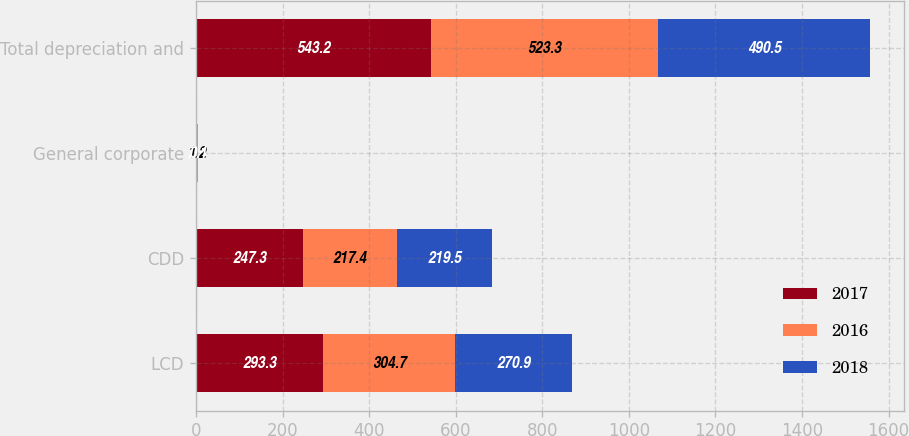<chart> <loc_0><loc_0><loc_500><loc_500><stacked_bar_chart><ecel><fcel>LCD<fcel>CDD<fcel>General corporate<fcel>Total depreciation and<nl><fcel>2017<fcel>293.3<fcel>247.3<fcel>2.6<fcel>543.2<nl><fcel>2016<fcel>304.7<fcel>217.4<fcel>1.2<fcel>523.3<nl><fcel>2018<fcel>270.9<fcel>219.5<fcel>0.1<fcel>490.5<nl></chart> 